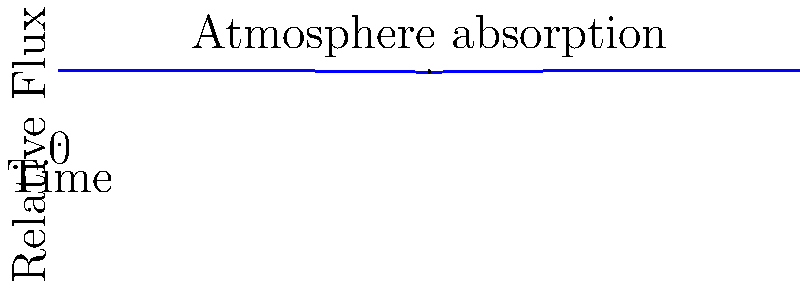Based on the transit light curve shown in the graph, which of the following statements is most likely true about the exoplanet's atmosphere?

A) It has a thick atmosphere with heavy molecules
B) It has a thin atmosphere with light molecules
C) It has no atmosphere
D) It has a thick atmosphere with light molecules To answer this question, we need to analyze the transit light curve:

1. The graph shows a dip in the relative flux as the exoplanet passes in front of its star.

2. The shape of the dip is important:
   - The bottom of the curve is rounded, not flat.
   - There's a gradual decrease and increase in flux before and after the main transit.

3. This gradual change indicates the presence of an atmosphere:
   - As the planet begins to transit, its atmosphere starts blocking some starlight before the solid body does.
   - After the main transit, the atmosphere continues to block some light.

4. The depth of the atmospheric absorption is relatively small compared to the main transit depth.

5. A thick atmosphere with heavy molecules would likely produce a deeper, more pronounced effect.

6. A thin atmosphere with light molecules explains the observed curve:
   - Light molecules (e.g., hydrogen, helium) extend higher in the atmosphere.
   - The thinness of the atmosphere results in a subtle effect on the light curve.

Therefore, based on the subtle atmospheric signature in the transit curve, the most likely explanation is a thin atmosphere composed of light molecules.
Answer: B) It has a thin atmosphere with light molecules 